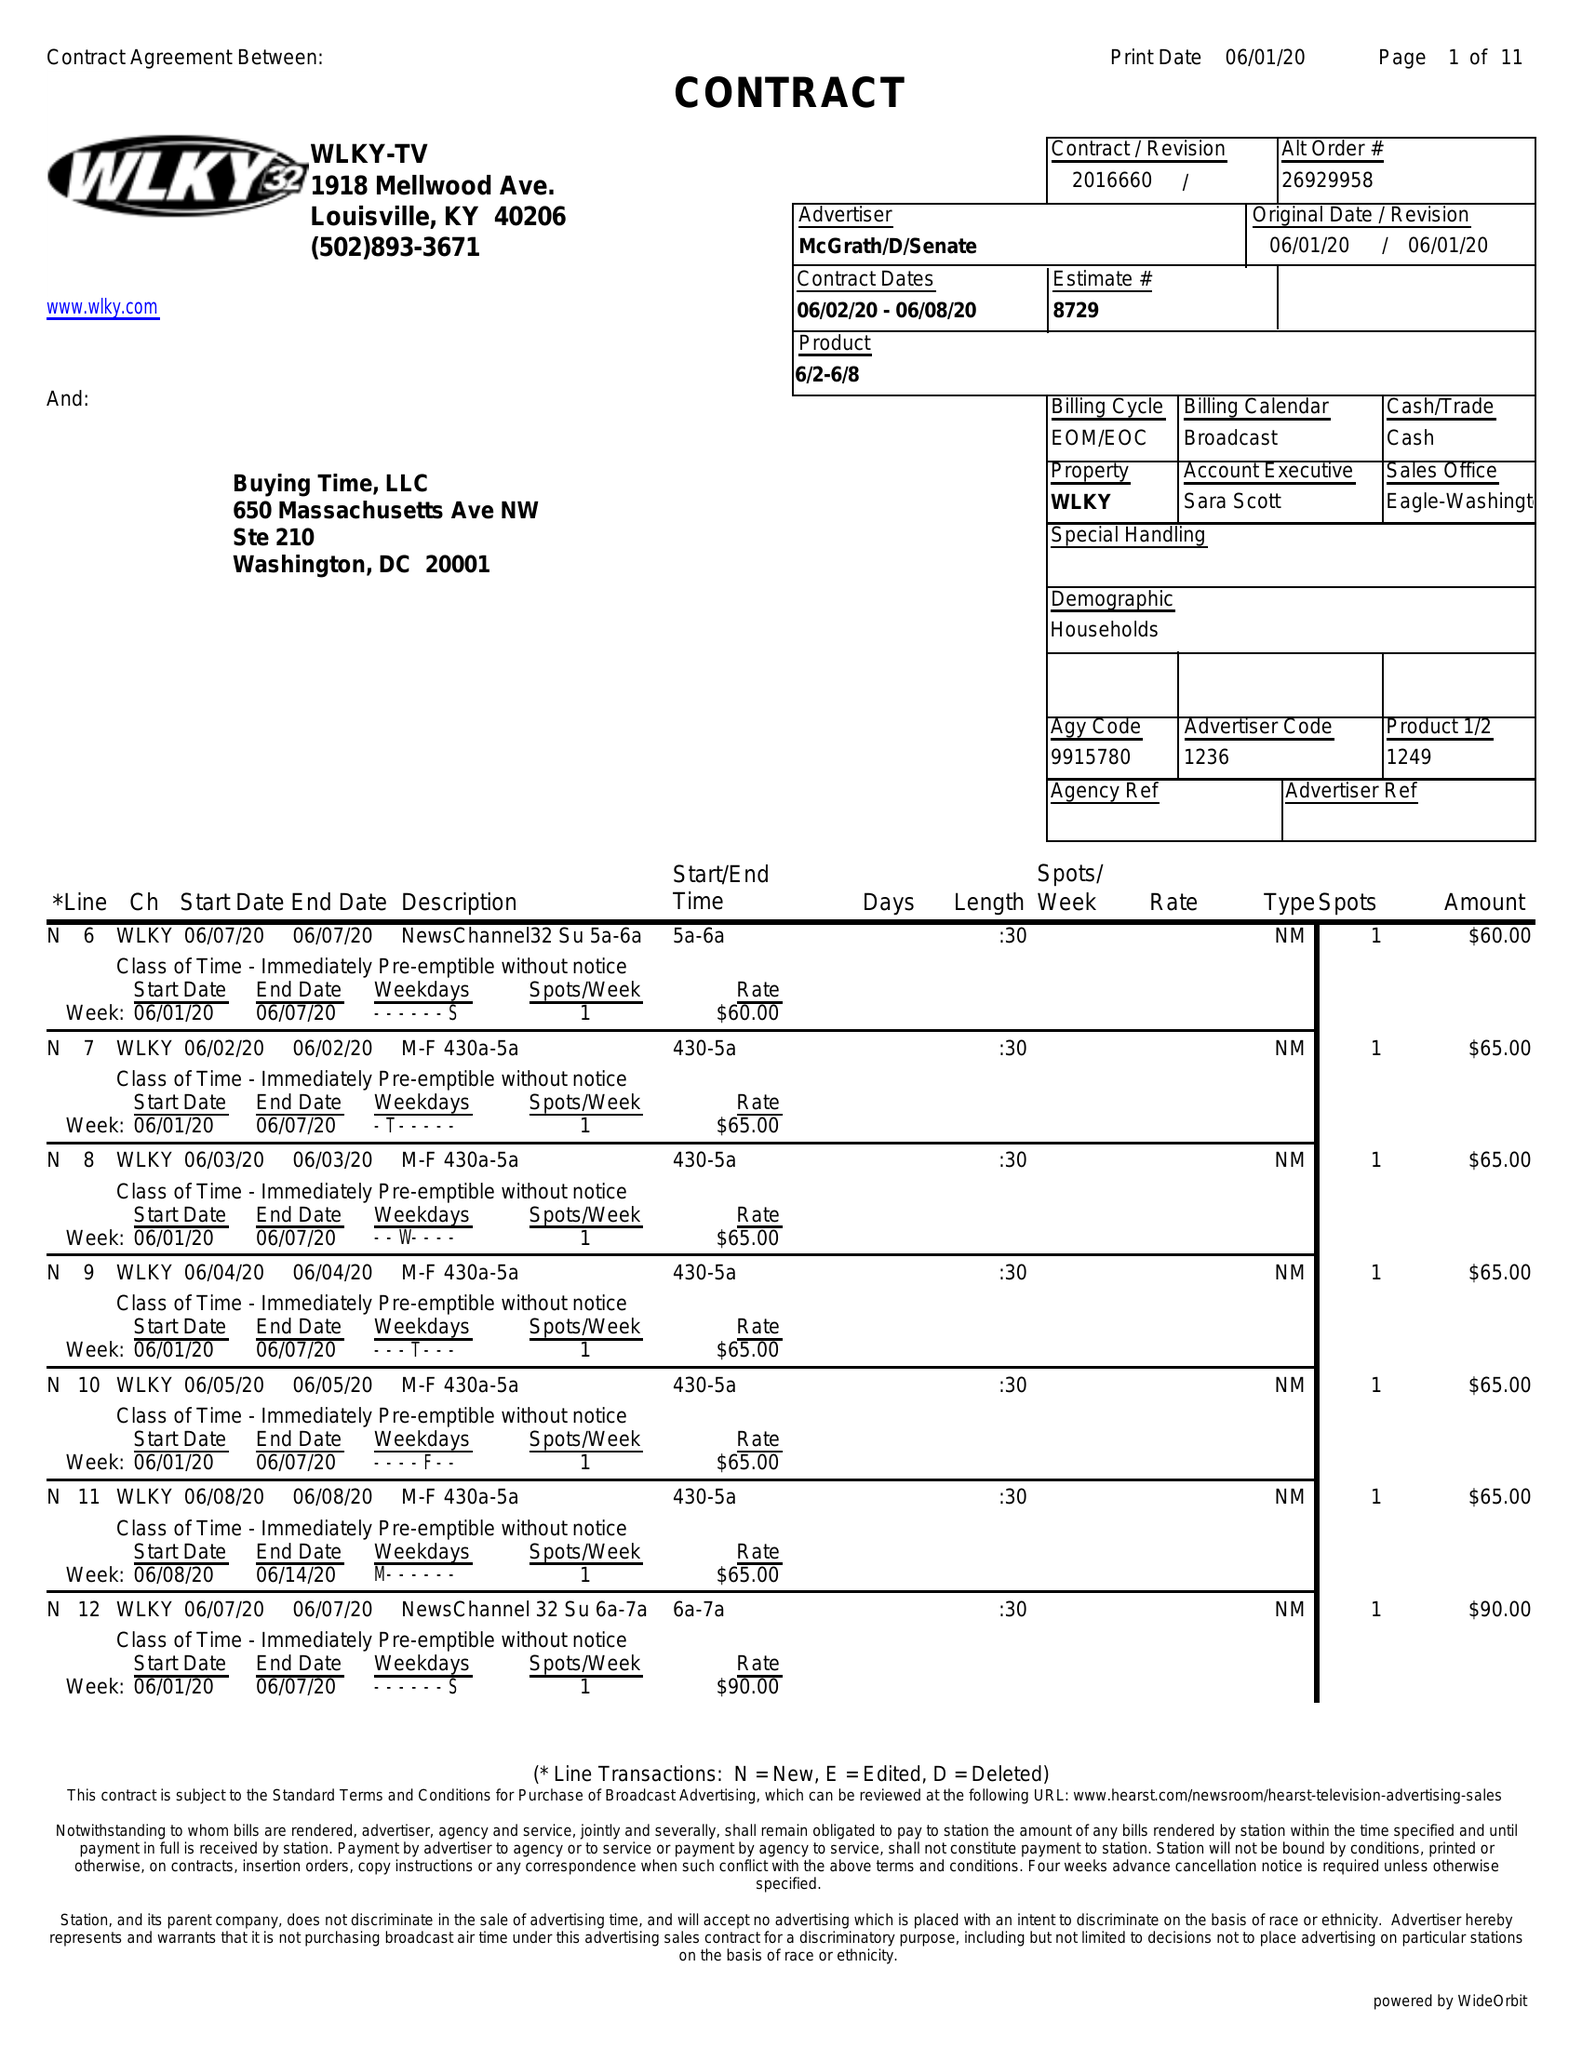What is the value for the flight_from?
Answer the question using a single word or phrase. 06/02/20 